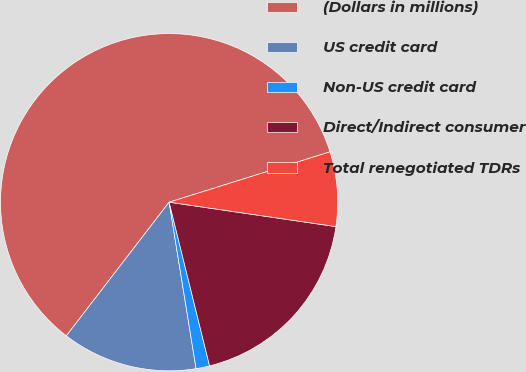Convert chart to OTSL. <chart><loc_0><loc_0><loc_500><loc_500><pie_chart><fcel>(Dollars in millions)<fcel>US credit card<fcel>Non-US credit card<fcel>Direct/Indirect consumer<fcel>Total renegotiated TDRs<nl><fcel>59.74%<fcel>12.99%<fcel>1.3%<fcel>18.83%<fcel>7.14%<nl></chart> 